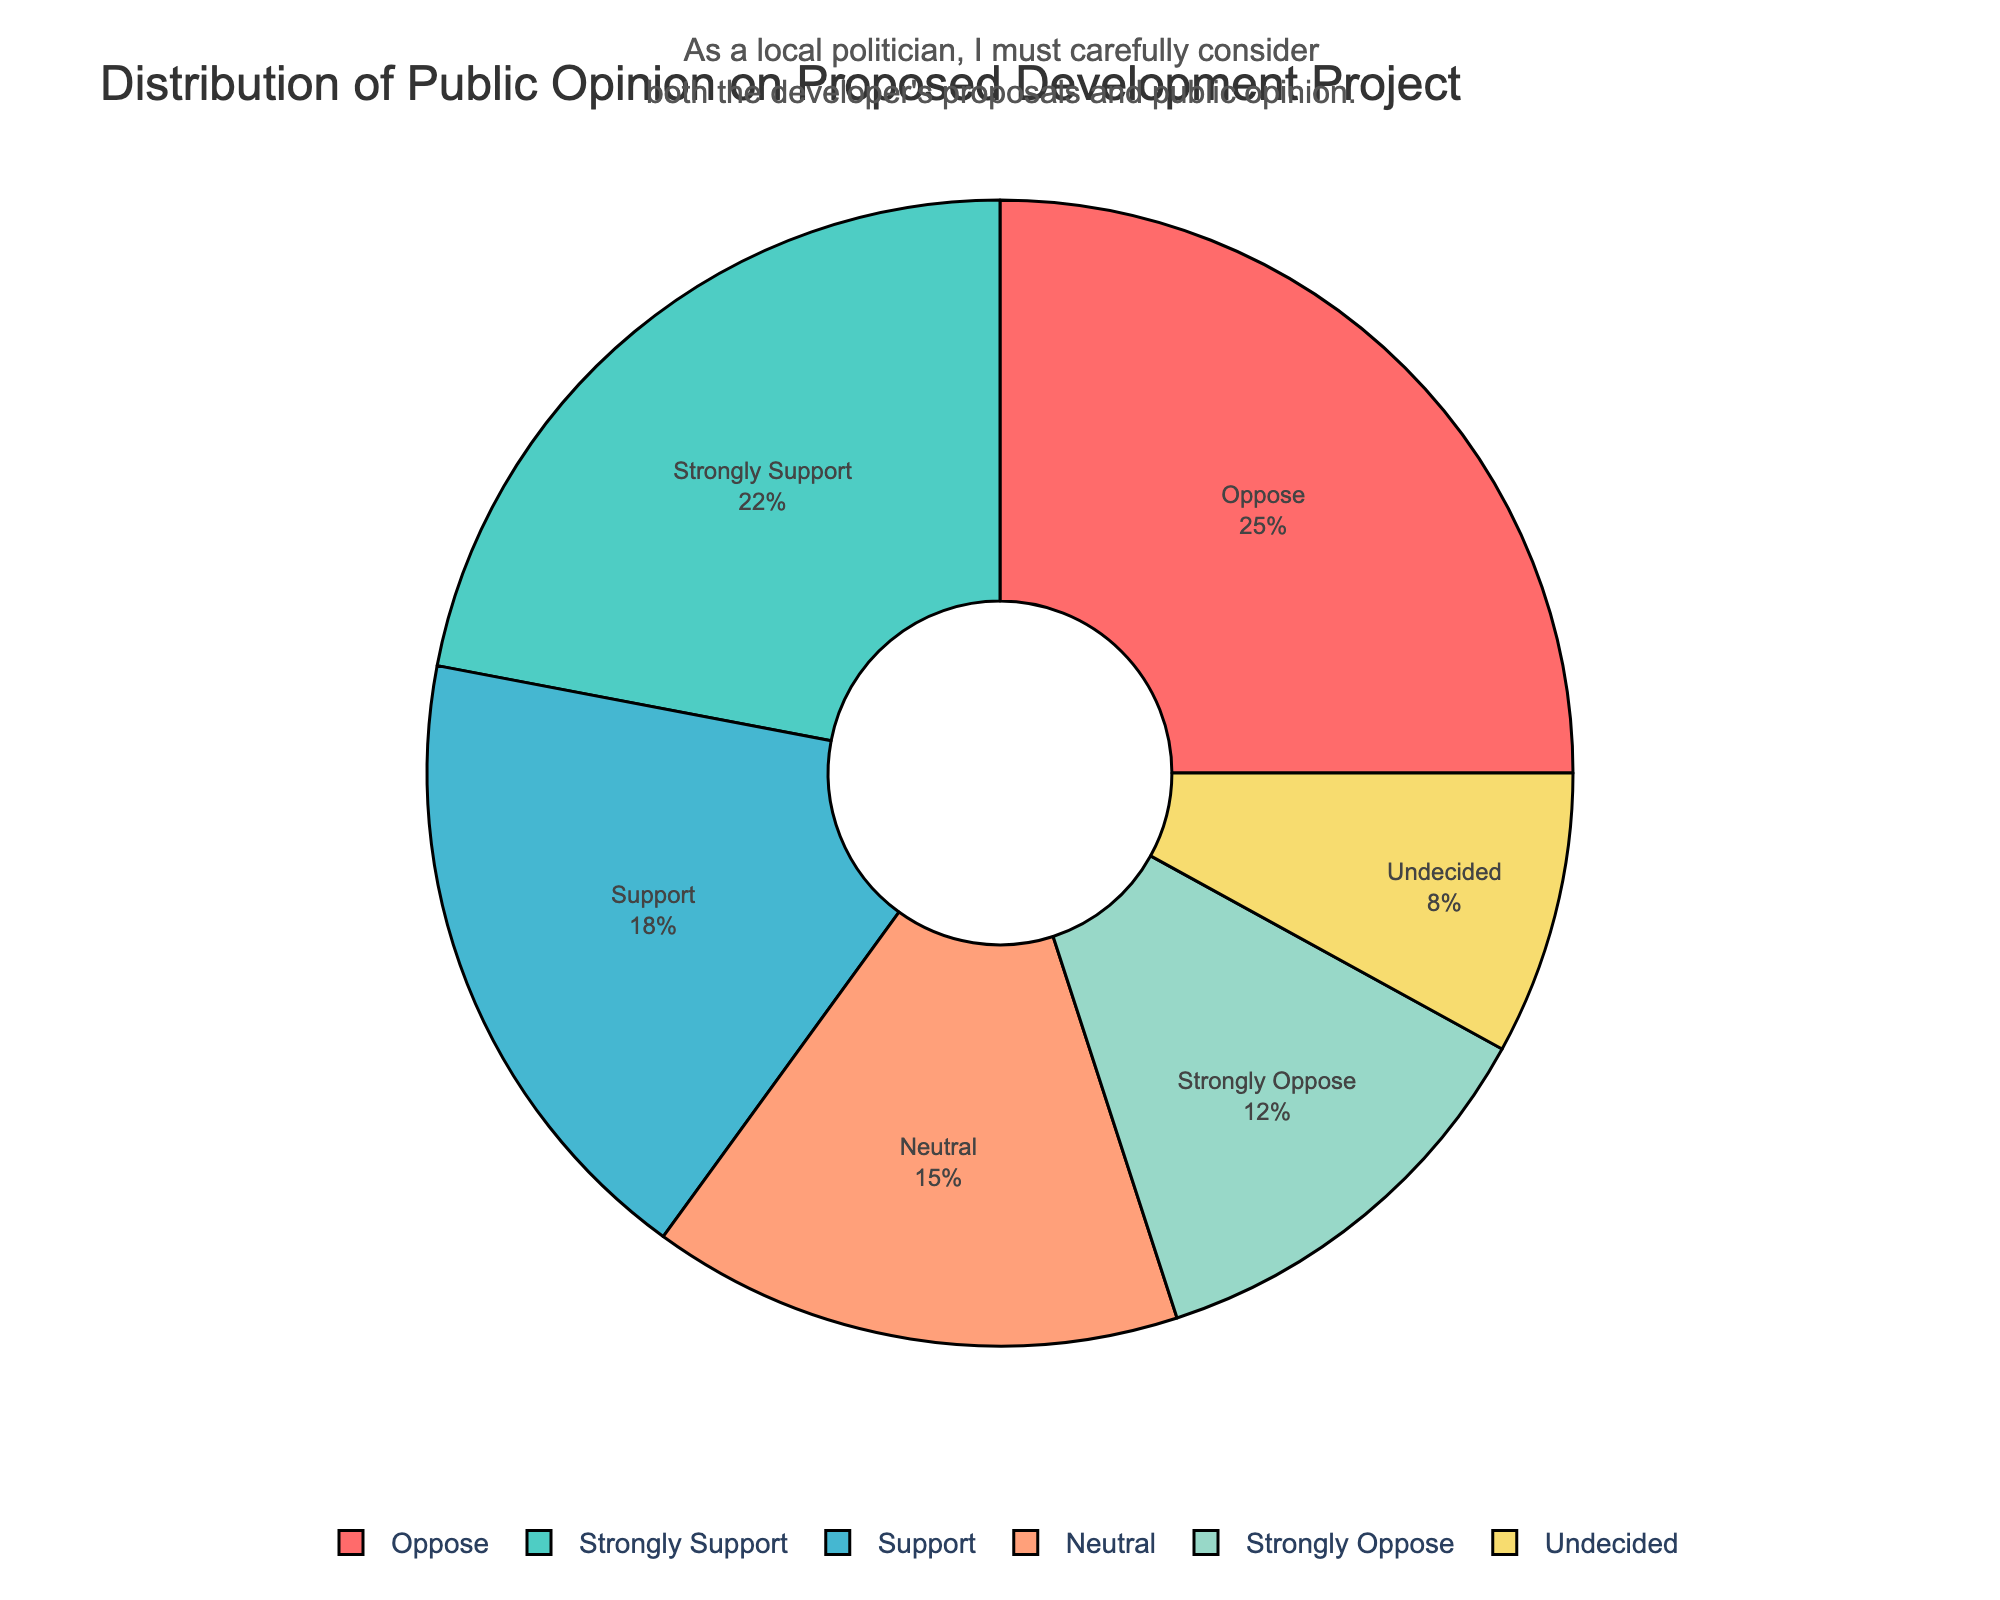What is the percentage of people who support (both strongly support and support) the proposed development project? The category "Strongly Support" has 22% and "Support" has 18%. Adding these together: 22% + 18% = 40%.
Answer: 40% Which group has the highest percentage of public opinion? The "Oppose" category has 25%, which is the highest among all the categories.
Answer: Oppose Is the percentage of people who are against (oppose and strongly oppose) the proposed development higher than those who are in favor (support and strongly support)? Summing the percentages for "Strongly Oppose" (12%) and "Oppose" (25%) gives 37%. Summing the percentages for "Strongly Support" (22%) and "Support" (18%) gives 40%. Since 37% < 40%, fewer people are against than in favor.
Answer: No How many more people are undecided compared to those who are neutral? The "Undecided" category has 8% and "Neutral" has 15%. Subtracting these: 15% - 8% = 7%.
Answer: 7% What is the combined percentage of people who have a clear opinion (either in favor or against) compared to those who do not have a clear opinion (neutral or undecided)? Summing percentages for "Strongly Support" (22%), "Support" (18%), "Oppose" (25%), and "Strongly Oppose" (12%) gives 77%. Summing "Neutral" (15%) and "Undecided" (8%) gives 23%. So, 77% compared to 23%.
Answer: 77% compared to 23% What percentage of the public opinion is captured by just the opposing (oppose and strongly oppose) categories? Adding "Oppose" (25%) and "Strongly Oppose" (12%) gives 25% + 12% = 37%.
Answer: 37% Is the percentage of people who are neutral or undecided less than those who support (either strongly or just support) the project? Summing "Neutral" (15%) and "Undecided" (8%) gives 23%. Summing "Strongly Support" (22%) and "Support" (18%) gives 40%. Since 23% < 40%, fewer people are neutral or undecided than those who support the project.
Answer: Yes What is the smallest category in the public opinion distribution? The "Undecided" category has the smallest percentage with 8%.
Answer: Undecided Considering the visual aspects of the pie chart, what is the position of the "Strongly Oppose" category in the legend? Looking at the legend, "Strongly Oppose" is positioned in the middle of the horizontal legend positions.
Answer: Middle 